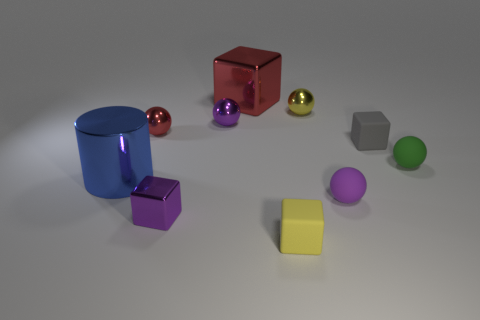Are there any patterns to the arrangement of the shapes? Upon closer inspection, there's no discernible pattern in the arrangement. The objects are placed without any obvious order, which could suggest the artist's intention for a more casual or natural scene. Alternatively, this randomness could be meant to challenge viewers to find a pattern or meaning, promoting engagement and thought. 